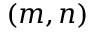<formula> <loc_0><loc_0><loc_500><loc_500>( m , n )</formula> 